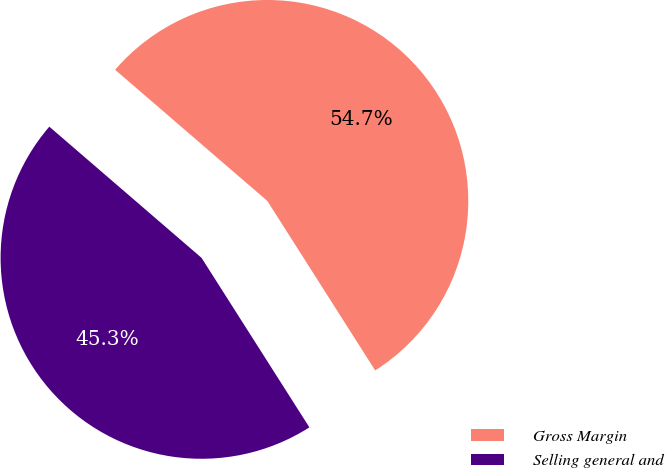Convert chart to OTSL. <chart><loc_0><loc_0><loc_500><loc_500><pie_chart><fcel>Gross Margin<fcel>Selling general and<nl><fcel>54.66%<fcel>45.34%<nl></chart> 